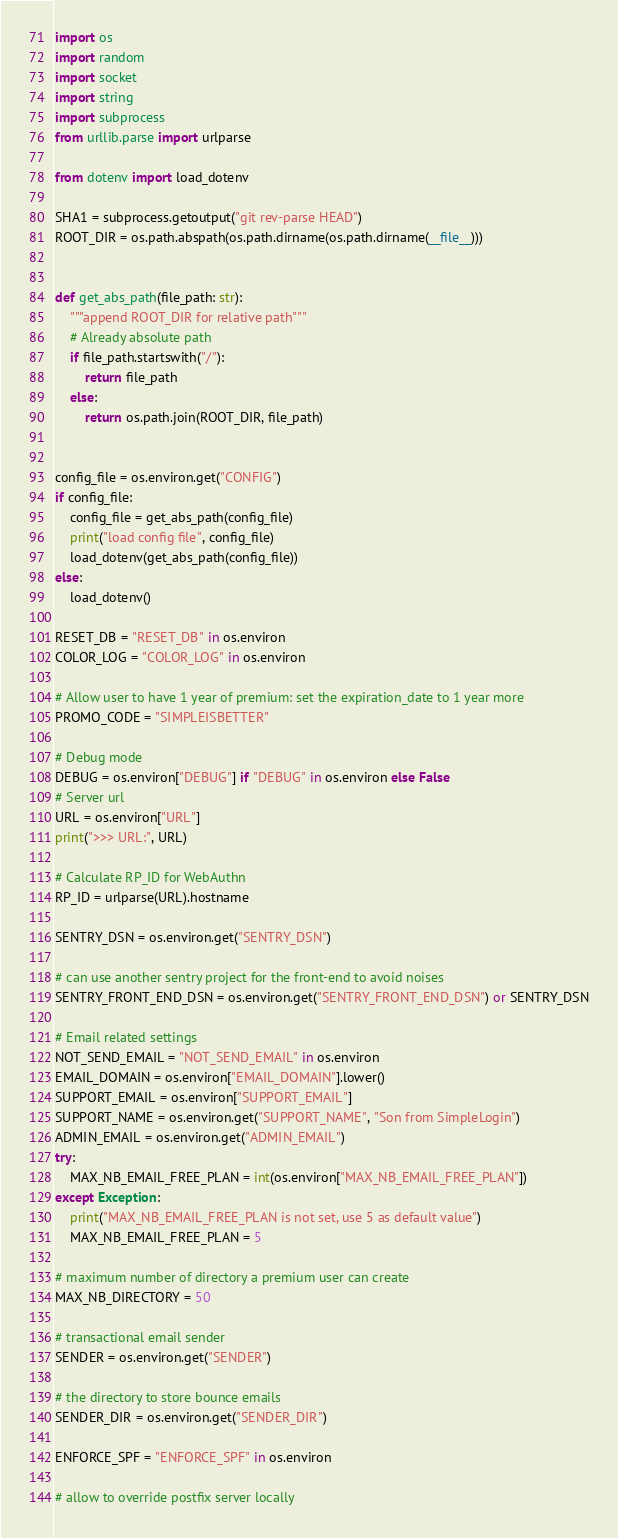<code> <loc_0><loc_0><loc_500><loc_500><_Python_>import os
import random
import socket
import string
import subprocess
from urllib.parse import urlparse

from dotenv import load_dotenv

SHA1 = subprocess.getoutput("git rev-parse HEAD")
ROOT_DIR = os.path.abspath(os.path.dirname(os.path.dirname(__file__)))


def get_abs_path(file_path: str):
    """append ROOT_DIR for relative path"""
    # Already absolute path
    if file_path.startswith("/"):
        return file_path
    else:
        return os.path.join(ROOT_DIR, file_path)


config_file = os.environ.get("CONFIG")
if config_file:
    config_file = get_abs_path(config_file)
    print("load config file", config_file)
    load_dotenv(get_abs_path(config_file))
else:
    load_dotenv()

RESET_DB = "RESET_DB" in os.environ
COLOR_LOG = "COLOR_LOG" in os.environ

# Allow user to have 1 year of premium: set the expiration_date to 1 year more
PROMO_CODE = "SIMPLEISBETTER"

# Debug mode
DEBUG = os.environ["DEBUG"] if "DEBUG" in os.environ else False
# Server url
URL = os.environ["URL"]
print(">>> URL:", URL)

# Calculate RP_ID for WebAuthn
RP_ID = urlparse(URL).hostname

SENTRY_DSN = os.environ.get("SENTRY_DSN")

# can use another sentry project for the front-end to avoid noises
SENTRY_FRONT_END_DSN = os.environ.get("SENTRY_FRONT_END_DSN") or SENTRY_DSN

# Email related settings
NOT_SEND_EMAIL = "NOT_SEND_EMAIL" in os.environ
EMAIL_DOMAIN = os.environ["EMAIL_DOMAIN"].lower()
SUPPORT_EMAIL = os.environ["SUPPORT_EMAIL"]
SUPPORT_NAME = os.environ.get("SUPPORT_NAME", "Son from SimpleLogin")
ADMIN_EMAIL = os.environ.get("ADMIN_EMAIL")
try:
    MAX_NB_EMAIL_FREE_PLAN = int(os.environ["MAX_NB_EMAIL_FREE_PLAN"])
except Exception:
    print("MAX_NB_EMAIL_FREE_PLAN is not set, use 5 as default value")
    MAX_NB_EMAIL_FREE_PLAN = 5

# maximum number of directory a premium user can create
MAX_NB_DIRECTORY = 50

# transactional email sender
SENDER = os.environ.get("SENDER")

# the directory to store bounce emails
SENDER_DIR = os.environ.get("SENDER_DIR")

ENFORCE_SPF = "ENFORCE_SPF" in os.environ

# allow to override postfix server locally</code> 